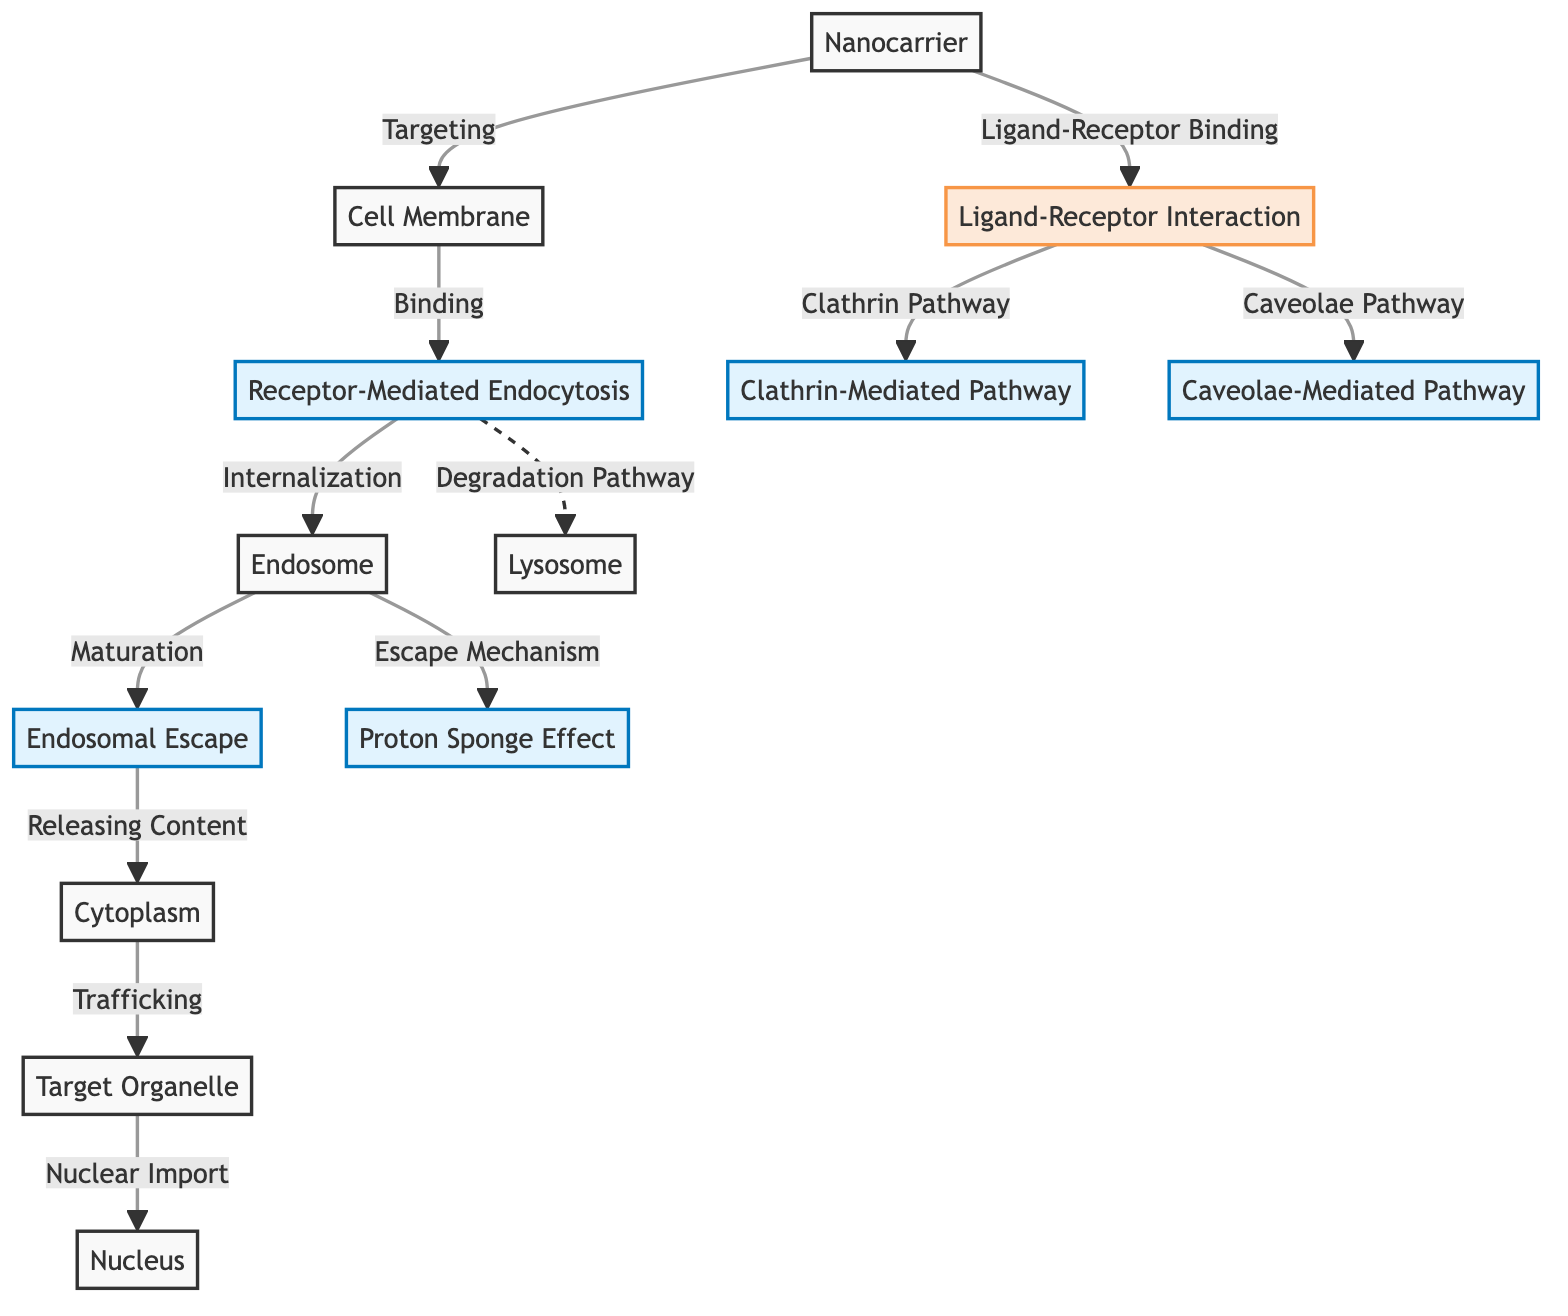What is the first node in the diagram? The first node in the diagram represents the starting point of the process, which is the "Nanocarrier".
Answer: Nanocarrier How many different pathways are identified for endocytosis in the diagram? The diagram identifies two distinct pathways for endocytosis: the "Clathrin-Mediated Pathway" and the "Caveolae-Mediated Pathway".
Answer: 2 What stage follows "Receptor-Mediated Endocytosis"? After "Receptor-Mediated Endocytosis", the next stage in the flow is "Endosome".
Answer: Endosome What is the relationship between "Endosome" and "Cytoplasm"? The relationship is that the "Endosome" matures and then releases its contents into the "Cytoplasm".
Answer: Releases Content What mechanism is involved after "Endosomal Escape"? After "Endosomal Escape", the "Cytoplasm" is reached, indicating that the contents of the endosome have been successfully released.
Answer: Cytoplasm Which node relates to the degradation pathway? The "Receptor-Mediated Endocytosis" node relates to the "Degradation Pathway", indicating that there is a potential for degradation to occur after this step.
Answer: Degradation Pathway What is the last organelle mentioned for trafficking in the diagram? The last organelle mentioned for trafficking in the diagram is the "Nucleus".
Answer: Nucleus What does the "Proton Sponge Effect" refer to in the context of the diagram? The "Proton Sponge Effect" is a mechanism that allows for the escape from the endosome, facilitating the delivery of the nanocarrier's contents into the cytoplasm.
Answer: Escape Mechanism How are ligand-receptor interactions linked to cellular uptake? Ligand-receptor interactions are crucial as they initiate the uptake process by binding the nanocarrier to the cell membrane, leading to endocytosis.
Answer: Ligand-Receptor Binding 